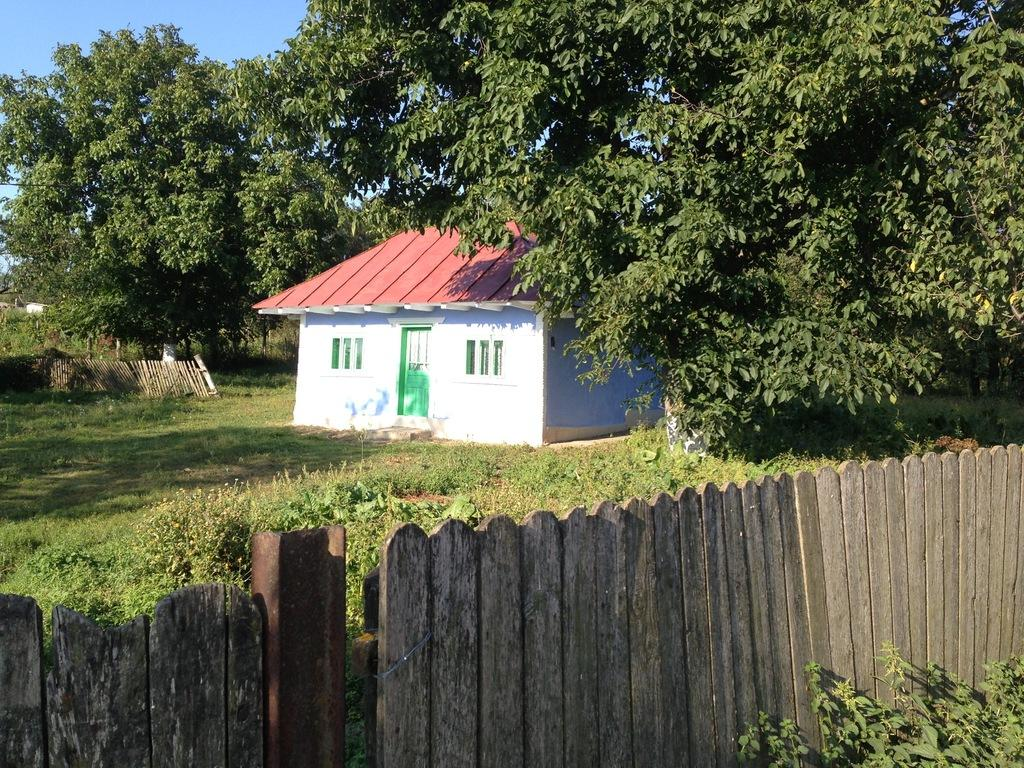What type of structure is visible in the image? There is a house in the image. What is located near the house? There is a fence in the image. What type of vegetation can be seen in the image? There are trees and grass in the image. What other objects are present in the image? There are other objects in the image, but their specific details are not mentioned in the provided facts. What is visible in the background of the image? The sky is visible in the background of the image. Where is the fence located in the image? There is a fence at the bottom of the image. What else can be found at the bottom of the image? Plants are present at the bottom of the image. What effect does the flight have on the ground in the image? There is no flight present in the image, so it is not possible to determine any effect on the ground. 